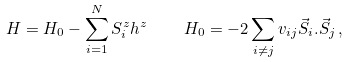<formula> <loc_0><loc_0><loc_500><loc_500>H = H _ { 0 } - \sum _ { i = 1 } ^ { N } S _ { i } ^ { z } h ^ { z } \quad H _ { 0 } = - 2 \sum _ { i \neq j } v _ { i j } { \vec { S } } _ { i } . { \vec { S } } _ { j } \, ,</formula> 